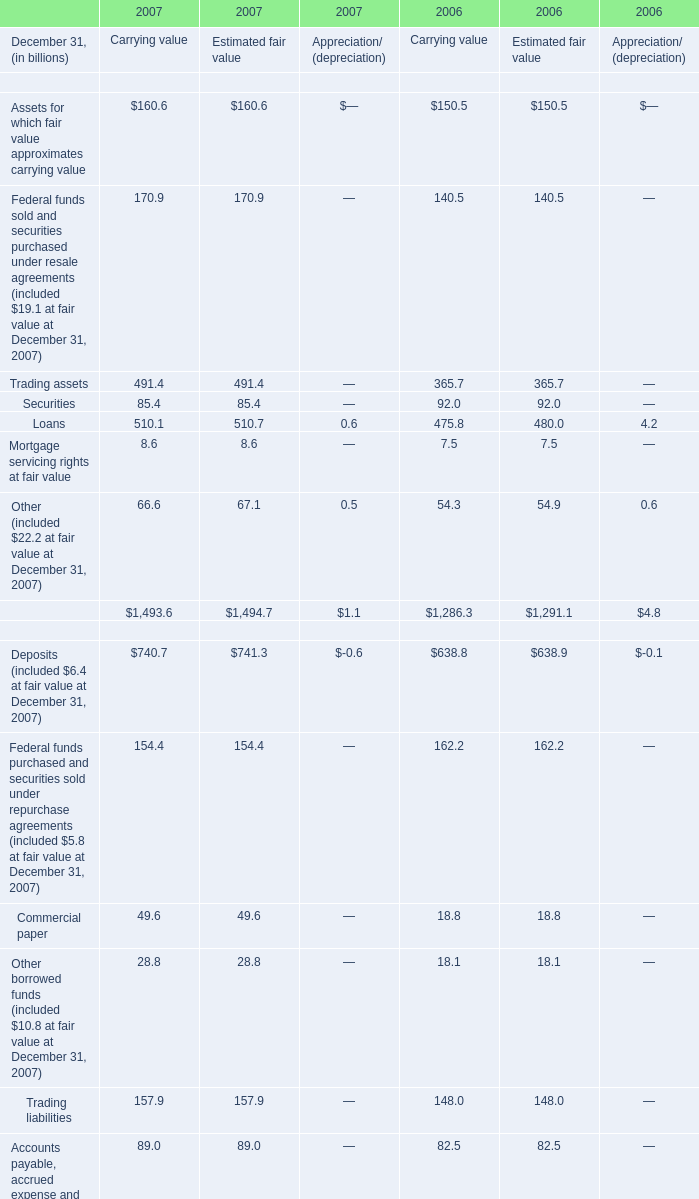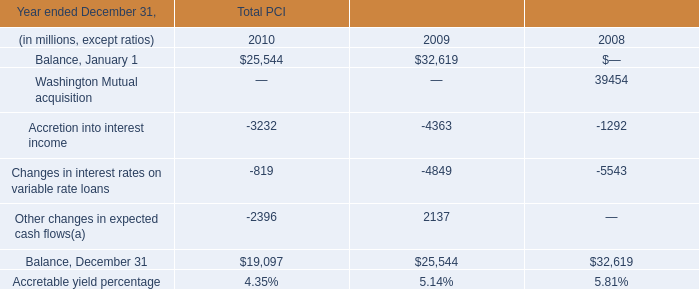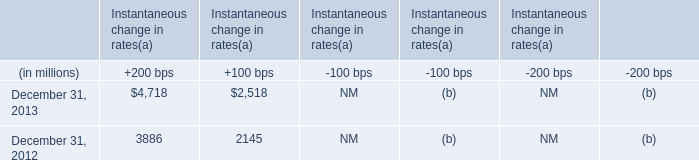What's the current increasing rate of Loans for Carrying value? 
Computations: ((510.1 - 475.8) / 475.8)
Answer: 0.07209. 